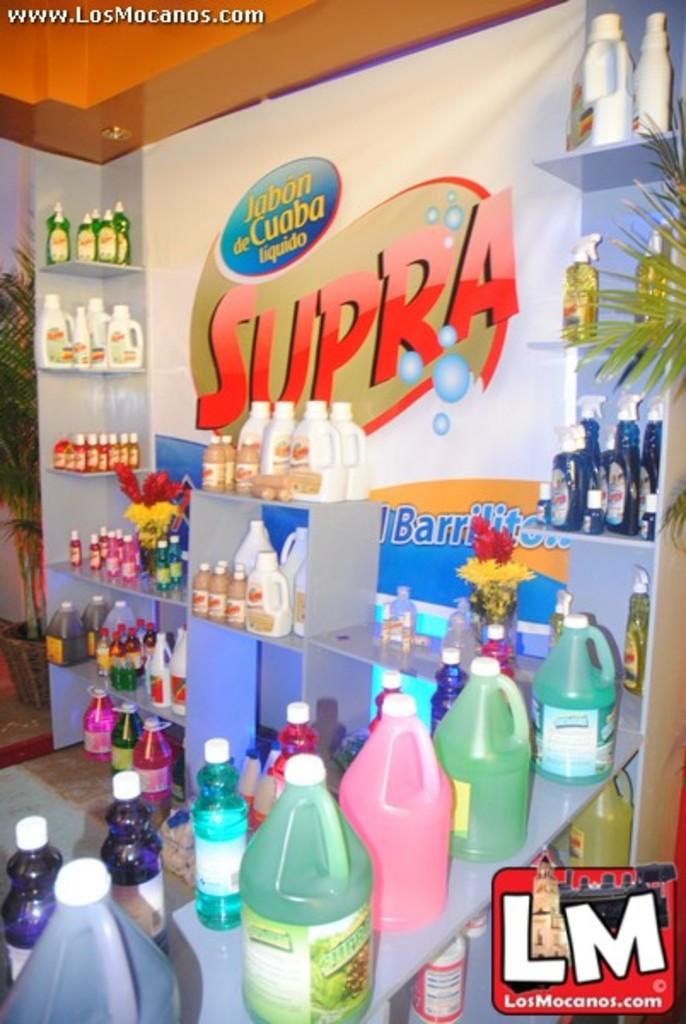<image>
Offer a succinct explanation of the picture presented. Banner with Jabon de Cuaba Liquido and Supra written on it 